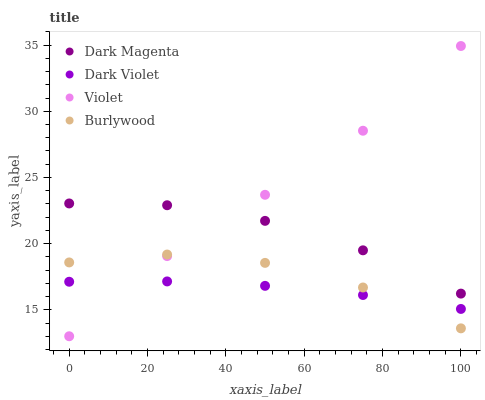Does Dark Violet have the minimum area under the curve?
Answer yes or no. Yes. Does Violet have the maximum area under the curve?
Answer yes or no. Yes. Does Dark Magenta have the minimum area under the curve?
Answer yes or no. No. Does Dark Magenta have the maximum area under the curve?
Answer yes or no. No. Is Dark Violet the smoothest?
Answer yes or no. Yes. Is Burlywood the roughest?
Answer yes or no. Yes. Is Dark Magenta the smoothest?
Answer yes or no. No. Is Dark Magenta the roughest?
Answer yes or no. No. Does Violet have the lowest value?
Answer yes or no. Yes. Does Dark Violet have the lowest value?
Answer yes or no. No. Does Violet have the highest value?
Answer yes or no. Yes. Does Dark Magenta have the highest value?
Answer yes or no. No. Is Burlywood less than Dark Magenta?
Answer yes or no. Yes. Is Dark Magenta greater than Burlywood?
Answer yes or no. Yes. Does Dark Magenta intersect Violet?
Answer yes or no. Yes. Is Dark Magenta less than Violet?
Answer yes or no. No. Is Dark Magenta greater than Violet?
Answer yes or no. No. Does Burlywood intersect Dark Magenta?
Answer yes or no. No. 